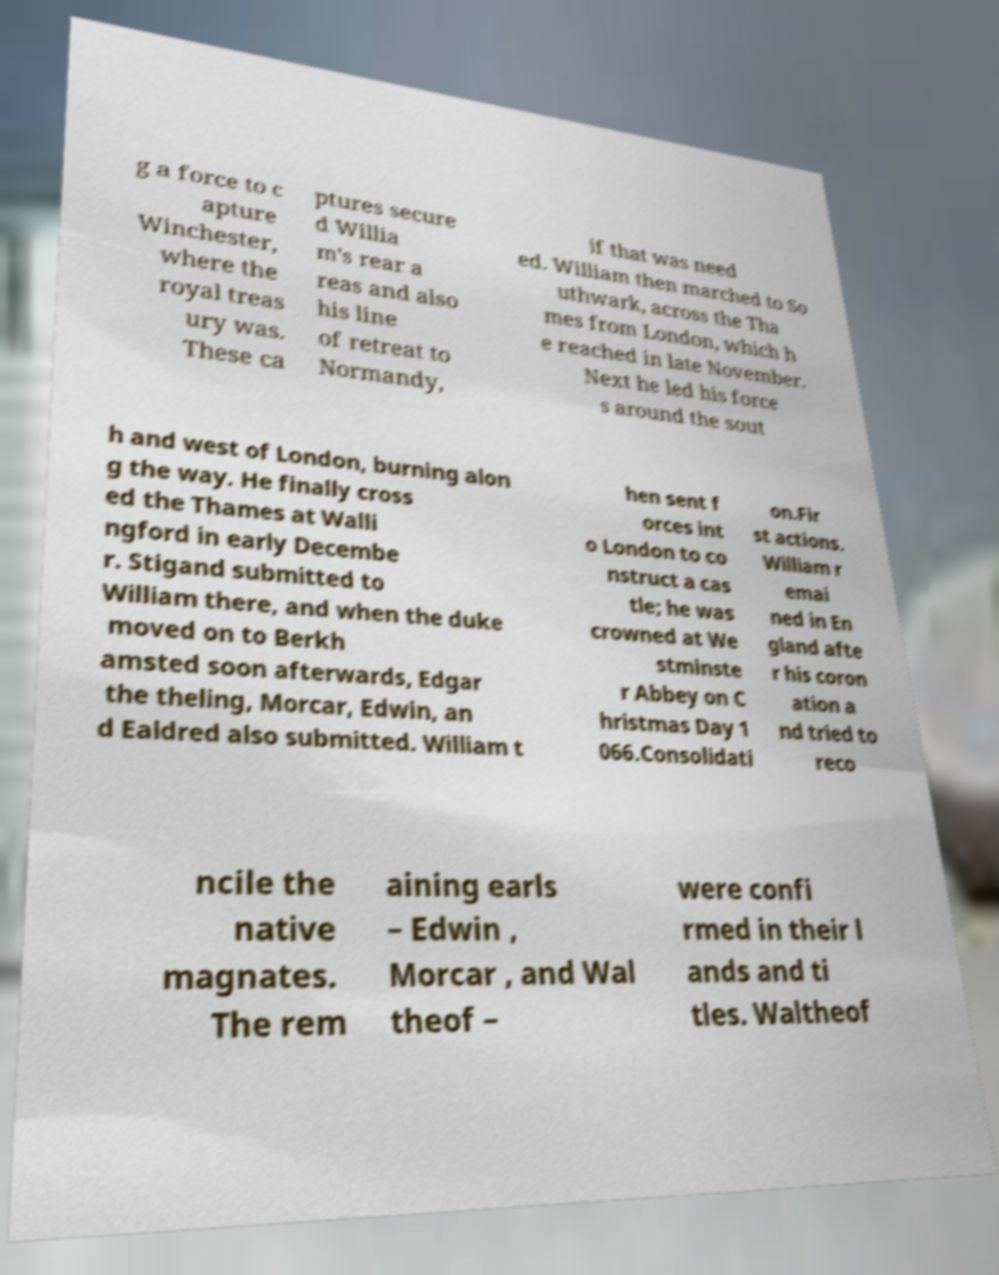Can you read and provide the text displayed in the image?This photo seems to have some interesting text. Can you extract and type it out for me? g a force to c apture Winchester, where the royal treas ury was. These ca ptures secure d Willia m's rear a reas and also his line of retreat to Normandy, if that was need ed. William then marched to So uthwark, across the Tha mes from London, which h e reached in late November. Next he led his force s around the sout h and west of London, burning alon g the way. He finally cross ed the Thames at Walli ngford in early Decembe r. Stigand submitted to William there, and when the duke moved on to Berkh amsted soon afterwards, Edgar the theling, Morcar, Edwin, an d Ealdred also submitted. William t hen sent f orces int o London to co nstruct a cas tle; he was crowned at We stminste r Abbey on C hristmas Day 1 066.Consolidati on.Fir st actions. William r emai ned in En gland afte r his coron ation a nd tried to reco ncile the native magnates. The rem aining earls – Edwin , Morcar , and Wal theof – were confi rmed in their l ands and ti tles. Waltheof 